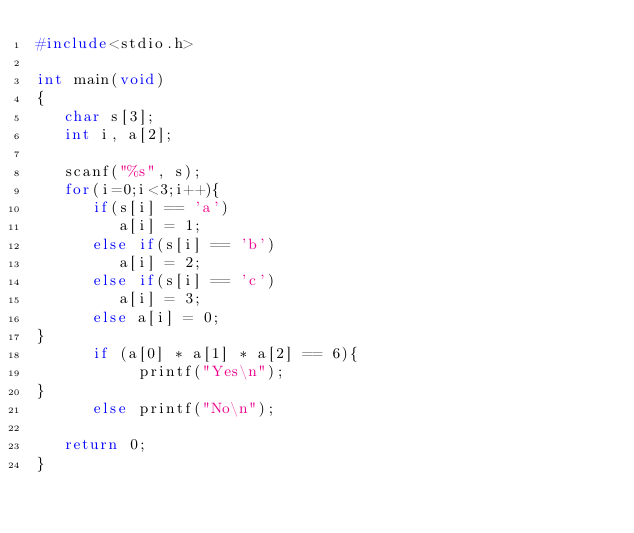<code> <loc_0><loc_0><loc_500><loc_500><_C_>#include<stdio.h>

int main(void)
{
   char s[3];
   int i, a[2];

   scanf("%s", s);
   for(i=0;i<3;i++){
      if(s[i] == 'a')
         a[i] = 1;
      else if(s[i] == 'b')
         a[i] = 2;
      else if(s[i] == 'c')
         a[i] = 3;
      else a[i] = 0;
}
      if (a[0] * a[1] * a[2] == 6){
           printf("Yes\n");
}
      else printf("No\n");

   return 0;
}
</code> 